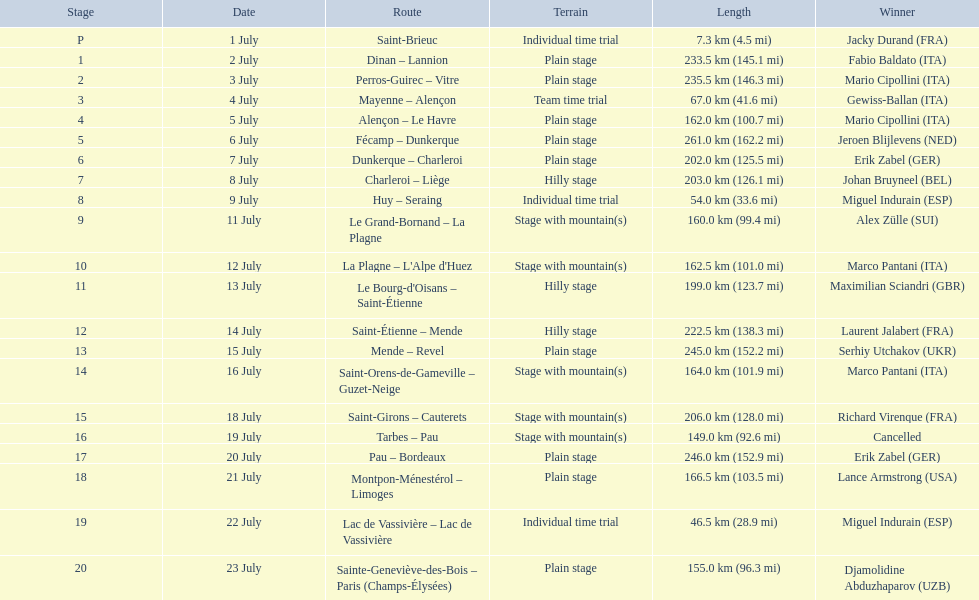What were the dates of the 1995 tour de france? 1 July, 2 July, 3 July, 4 July, 5 July, 6 July, 7 July, 8 July, 9 July, 11 July, 12 July, 13 July, 14 July, 15 July, 16 July, 18 July, 19 July, 20 July, 21 July, 22 July, 23 July. What was the length for july 8th? 203.0 km (126.1 mi). 